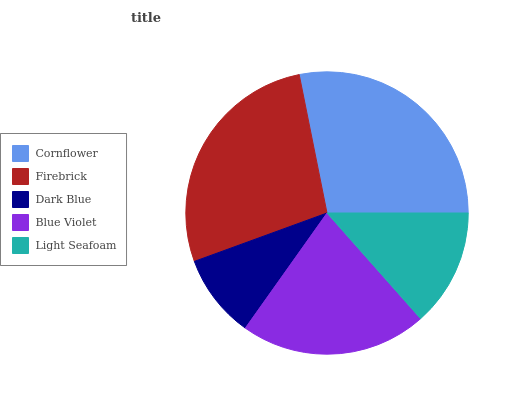Is Dark Blue the minimum?
Answer yes or no. Yes. Is Cornflower the maximum?
Answer yes or no. Yes. Is Firebrick the minimum?
Answer yes or no. No. Is Firebrick the maximum?
Answer yes or no. No. Is Cornflower greater than Firebrick?
Answer yes or no. Yes. Is Firebrick less than Cornflower?
Answer yes or no. Yes. Is Firebrick greater than Cornflower?
Answer yes or no. No. Is Cornflower less than Firebrick?
Answer yes or no. No. Is Blue Violet the high median?
Answer yes or no. Yes. Is Blue Violet the low median?
Answer yes or no. Yes. Is Dark Blue the high median?
Answer yes or no. No. Is Light Seafoam the low median?
Answer yes or no. No. 